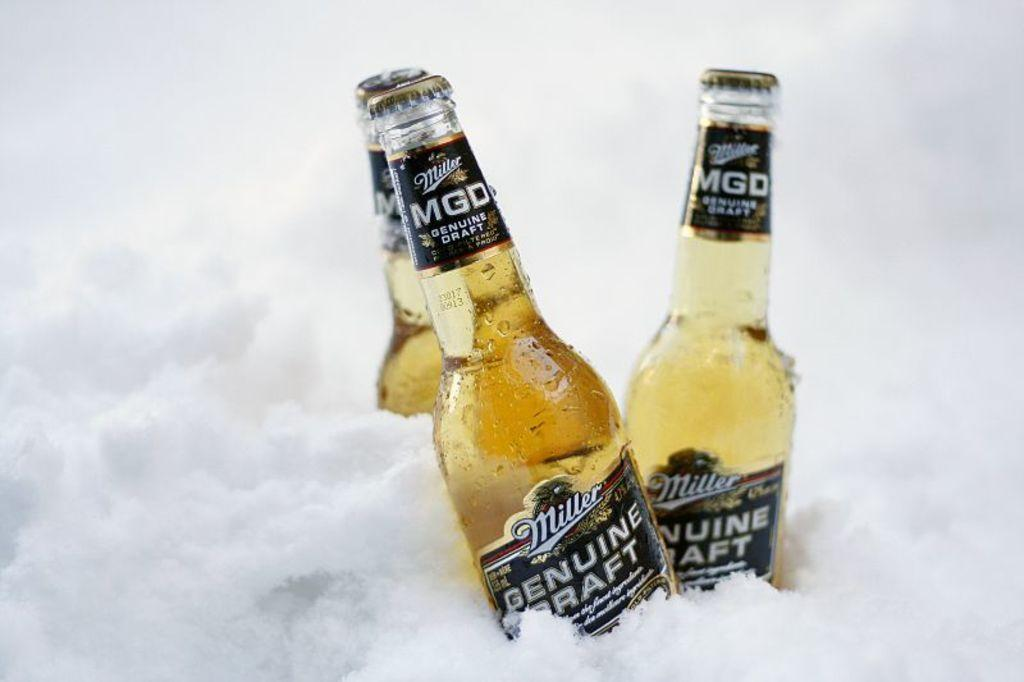<image>
Write a terse but informative summary of the picture. three bottles of Miller MGD sit in a pile of ice 